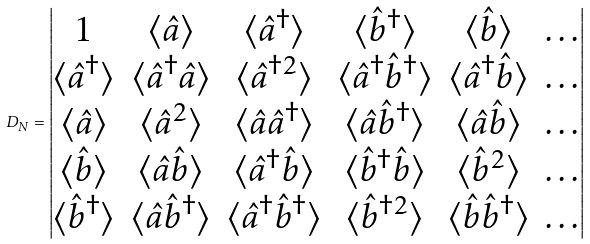Convert formula to latex. <formula><loc_0><loc_0><loc_500><loc_500>D _ { N } = \begin{vmatrix} 1 & \langle \hat { a } \rangle & \langle \hat { a } ^ { \dagger } \rangle & \langle \hat { b } ^ { \dagger } \rangle & \langle \hat { b } \rangle & \dots \\ \langle \hat { a } ^ { \dagger } \rangle & \langle \hat { a } ^ { \dagger } \hat { a } \rangle & \langle \hat { a } ^ { \dagger 2 } \rangle & \langle \hat { a } ^ { \dagger } \hat { b } ^ { \dagger } \rangle & \langle \hat { a } ^ { \dagger } \hat { b } \rangle & \dots \\ \langle \hat { a } \rangle & \langle \hat { a } ^ { 2 } \rangle & \langle \hat { a } \hat { a } ^ { \dagger } \rangle & \langle \hat { a } \hat { b } ^ { \dagger } \rangle & \langle \hat { a } \hat { b } \rangle & \dots \\ \langle \hat { b } \rangle & \langle \hat { a } \hat { b } \rangle & \langle \hat { a } ^ { \dagger } \hat { b } \rangle & \langle \hat { b } ^ { \dagger } \hat { b } \rangle & \langle \hat { b } ^ { 2 } \rangle & \dots \\ \langle \hat { b } ^ { \dagger } \rangle & \langle \hat { a } \hat { b } ^ { \dagger } \rangle & \langle \hat { a } ^ { \dagger } \hat { b } ^ { \dagger } \rangle & \langle \hat { b } ^ { \dagger 2 } \rangle & \langle \hat { b } \hat { b } ^ { \dagger } \rangle & \dots \\ \end{vmatrix}</formula> 